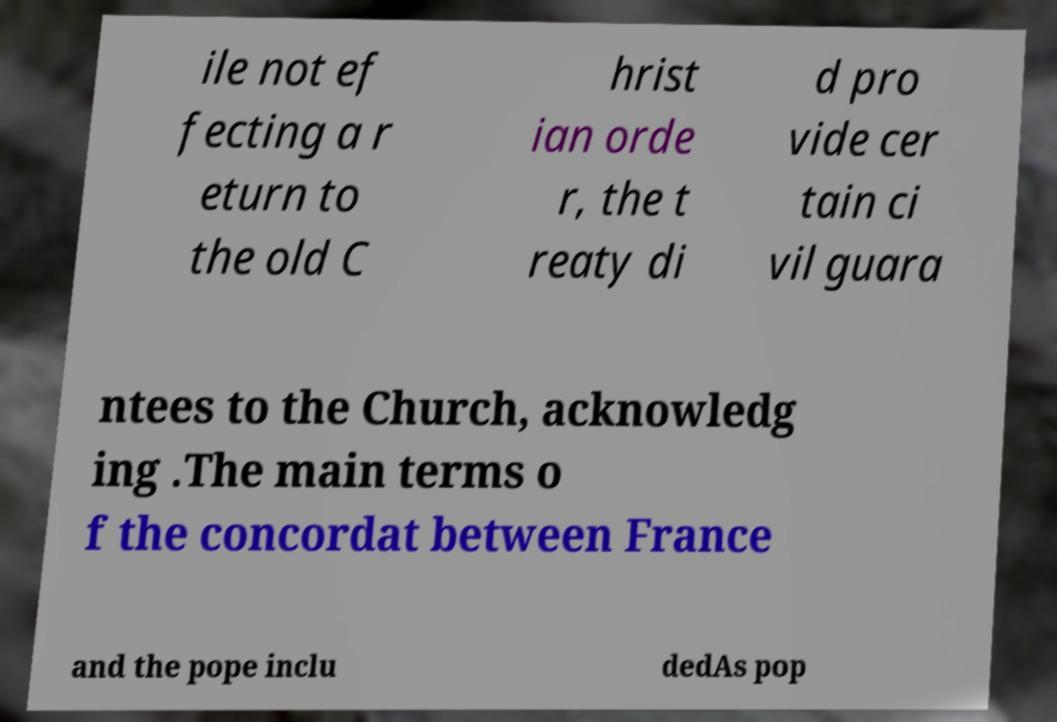Please read and relay the text visible in this image. What does it say? ile not ef fecting a r eturn to the old C hrist ian orde r, the t reaty di d pro vide cer tain ci vil guara ntees to the Church, acknowledg ing .The main terms o f the concordat between France and the pope inclu dedAs pop 